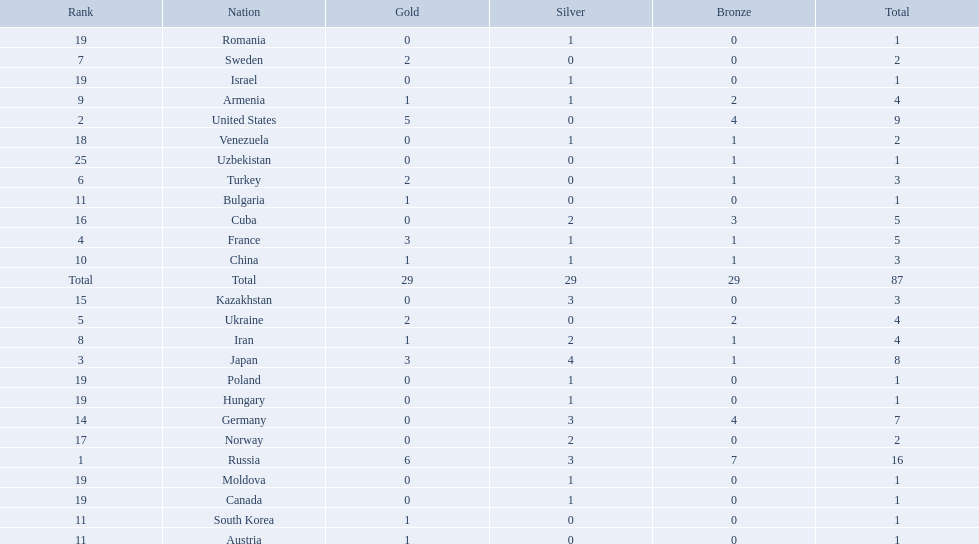Which nations only won less then 5 medals? Ukraine, Turkey, Sweden, Iran, Armenia, China, Austria, Bulgaria, South Korea, Germany, Kazakhstan, Norway, Venezuela, Canada, Hungary, Israel, Moldova, Poland, Romania, Uzbekistan. Which of these were not asian nations? Ukraine, Turkey, Sweden, Iran, Armenia, Austria, Bulgaria, Germany, Kazakhstan, Norway, Venezuela, Canada, Hungary, Israel, Moldova, Poland, Romania, Uzbekistan. Which of those did not win any silver medals? Ukraine, Turkey, Sweden, Austria, Bulgaria, Uzbekistan. Which ones of these had only one medal total? Austria, Bulgaria, Uzbekistan. Which of those would be listed first alphabetically? Austria. 